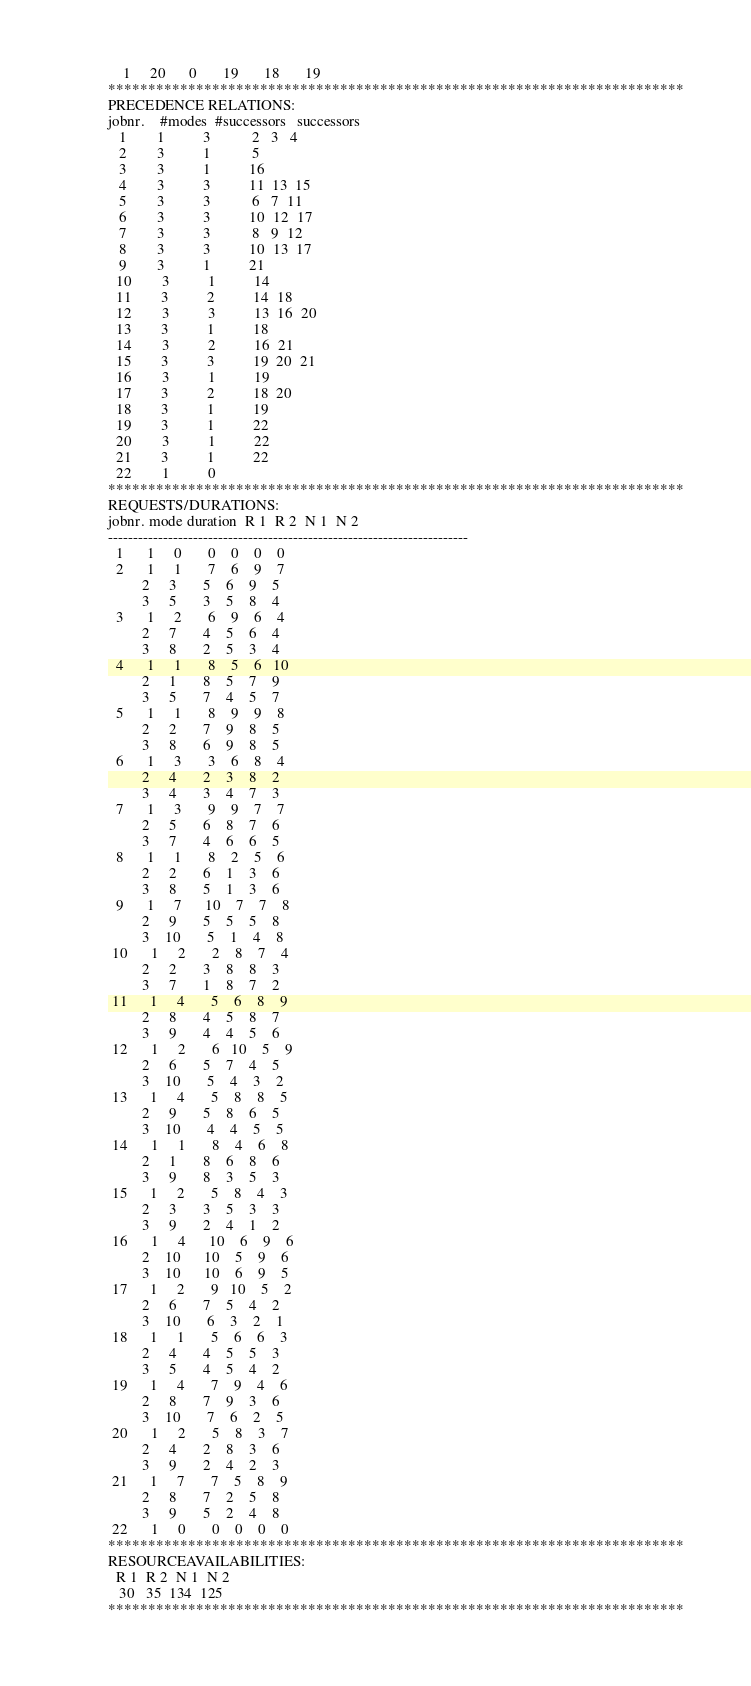Convert code to text. <code><loc_0><loc_0><loc_500><loc_500><_ObjectiveC_>    1     20      0       19       18       19
************************************************************************
PRECEDENCE RELATIONS:
jobnr.    #modes  #successors   successors
   1        1          3           2   3   4
   2        3          1           5
   3        3          1          16
   4        3          3          11  13  15
   5        3          3           6   7  11
   6        3          3          10  12  17
   7        3          3           8   9  12
   8        3          3          10  13  17
   9        3          1          21
  10        3          1          14
  11        3          2          14  18
  12        3          3          13  16  20
  13        3          1          18
  14        3          2          16  21
  15        3          3          19  20  21
  16        3          1          19
  17        3          2          18  20
  18        3          1          19
  19        3          1          22
  20        3          1          22
  21        3          1          22
  22        1          0        
************************************************************************
REQUESTS/DURATIONS:
jobnr. mode duration  R 1  R 2  N 1  N 2
------------------------------------------------------------------------
  1      1     0       0    0    0    0
  2      1     1       7    6    9    7
         2     3       5    6    9    5
         3     5       3    5    8    4
  3      1     2       6    9    6    4
         2     7       4    5    6    4
         3     8       2    5    3    4
  4      1     1       8    5    6   10
         2     1       8    5    7    9
         3     5       7    4    5    7
  5      1     1       8    9    9    8
         2     2       7    9    8    5
         3     8       6    9    8    5
  6      1     3       3    6    8    4
         2     4       2    3    8    2
         3     4       3    4    7    3
  7      1     3       9    9    7    7
         2     5       6    8    7    6
         3     7       4    6    6    5
  8      1     1       8    2    5    6
         2     2       6    1    3    6
         3     8       5    1    3    6
  9      1     7      10    7    7    8
         2     9       5    5    5    8
         3    10       5    1    4    8
 10      1     2       2    8    7    4
         2     2       3    8    8    3
         3     7       1    8    7    2
 11      1     4       5    6    8    9
         2     8       4    5    8    7
         3     9       4    4    5    6
 12      1     2       6   10    5    9
         2     6       5    7    4    5
         3    10       5    4    3    2
 13      1     4       5    8    8    5
         2     9       5    8    6    5
         3    10       4    4    5    5
 14      1     1       8    4    6    8
         2     1       8    6    8    6
         3     9       8    3    5    3
 15      1     2       5    8    4    3
         2     3       3    5    3    3
         3     9       2    4    1    2
 16      1     4      10    6    9    6
         2    10      10    5    9    6
         3    10      10    6    9    5
 17      1     2       9   10    5    2
         2     6       7    5    4    2
         3    10       6    3    2    1
 18      1     1       5    6    6    3
         2     4       4    5    5    3
         3     5       4    5    4    2
 19      1     4       7    9    4    6
         2     8       7    9    3    6
         3    10       7    6    2    5
 20      1     2       5    8    3    7
         2     4       2    8    3    6
         3     9       2    4    2    3
 21      1     7       7    5    8    9
         2     8       7    2    5    8
         3     9       5    2    4    8
 22      1     0       0    0    0    0
************************************************************************
RESOURCEAVAILABILITIES:
  R 1  R 2  N 1  N 2
   30   35  134  125
************************************************************************
</code> 